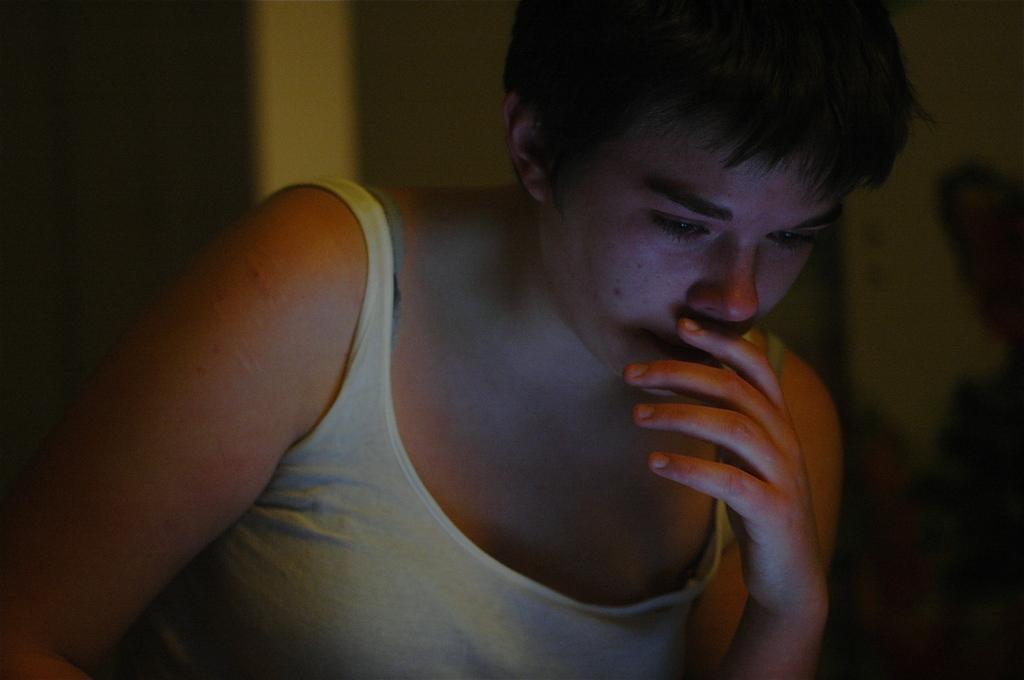Can you describe this image briefly? In this image I can see a person wearing a white vest. The background is blurred. 